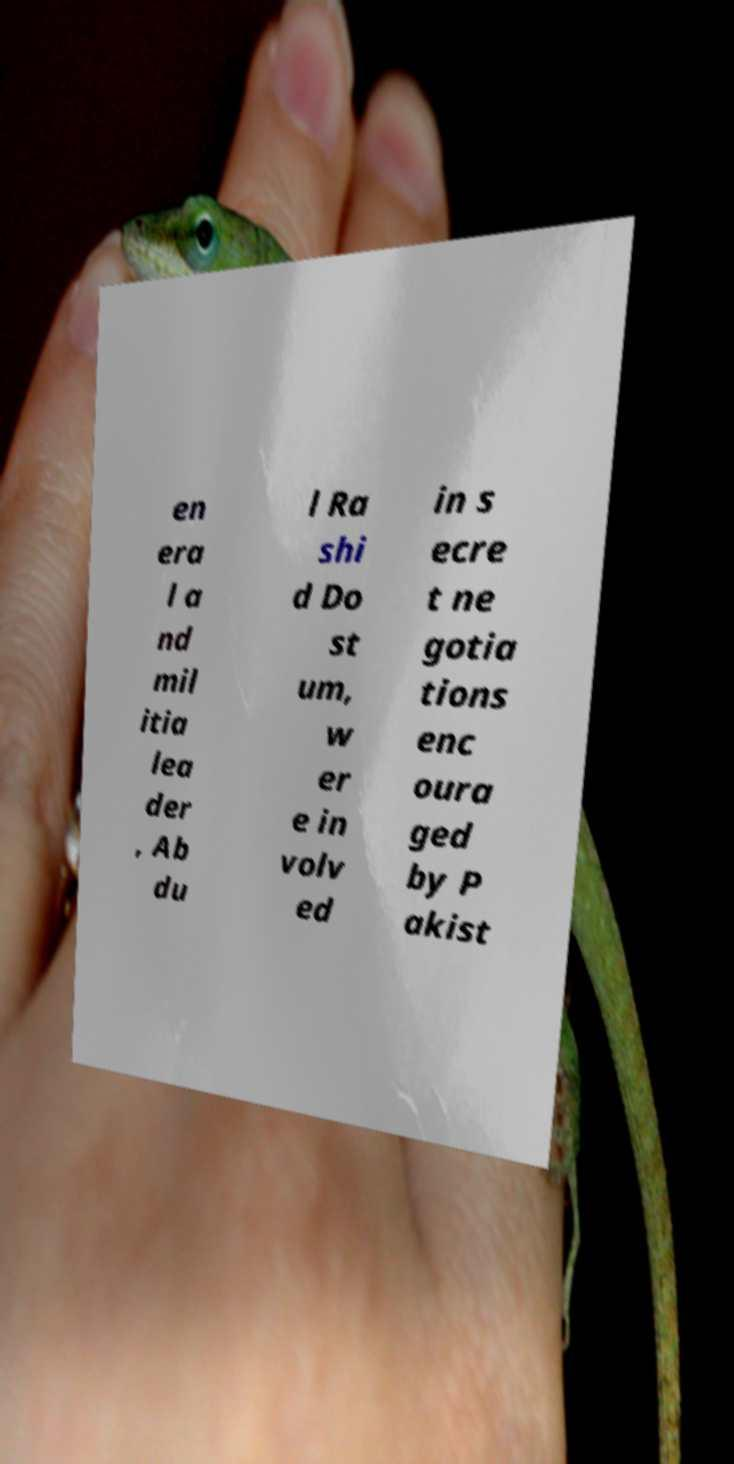What messages or text are displayed in this image? I need them in a readable, typed format. en era l a nd mil itia lea der , Ab du l Ra shi d Do st um, w er e in volv ed in s ecre t ne gotia tions enc oura ged by P akist 